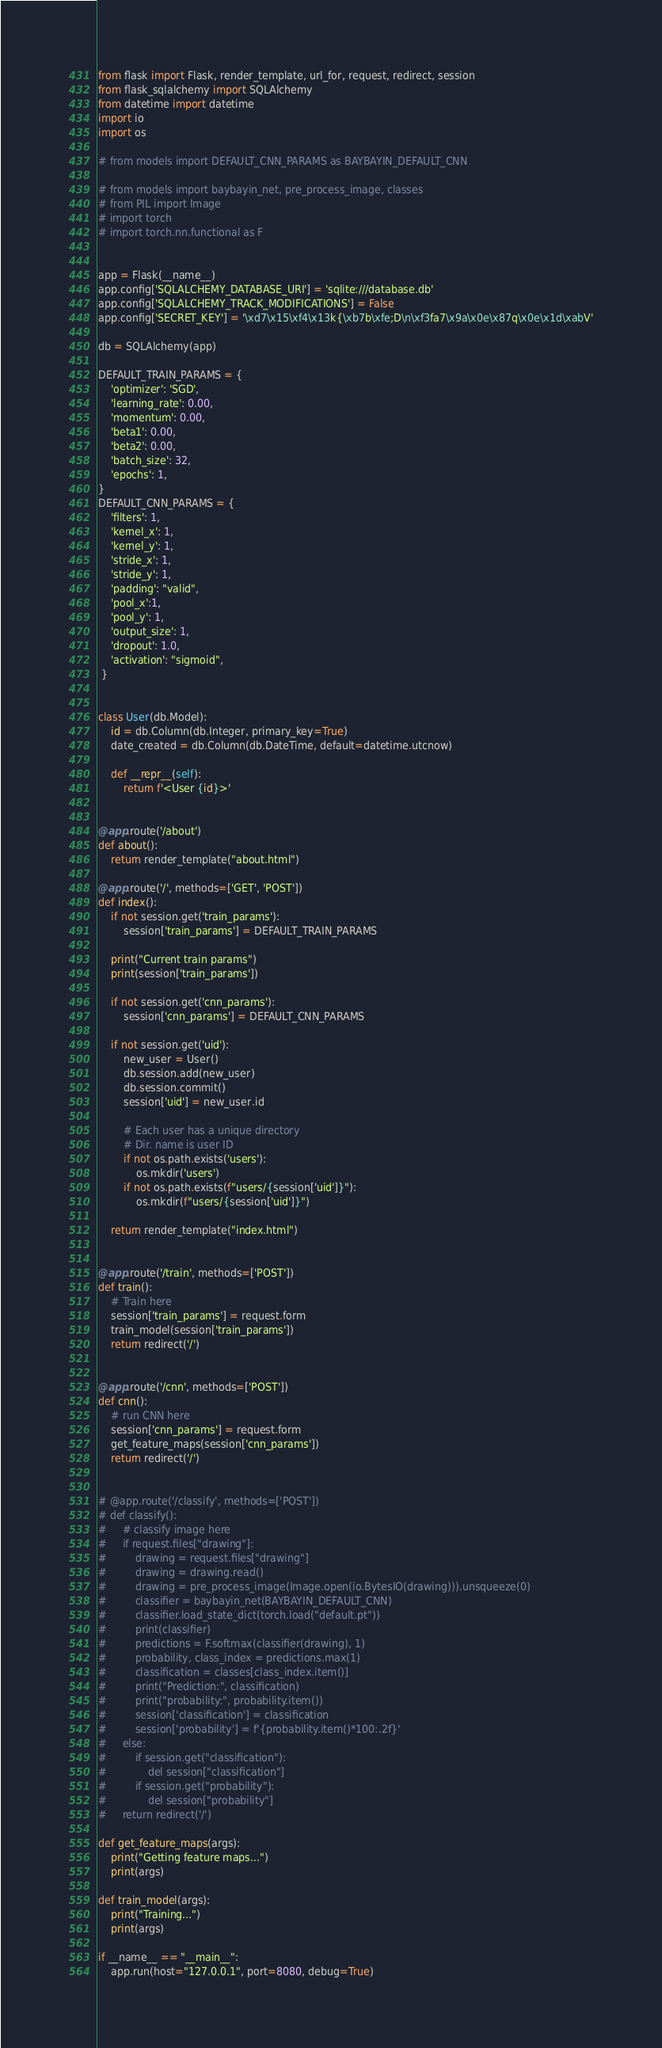Convert code to text. <code><loc_0><loc_0><loc_500><loc_500><_Python_>from flask import Flask, render_template, url_for, request, redirect, session
from flask_sqlalchemy import SQLAlchemy
from datetime import datetime
import io
import os

# from models import DEFAULT_CNN_PARAMS as BAYBAYIN_DEFAULT_CNN

# from models import baybayin_net, pre_process_image, classes
# from PIL import Image
# import torch
# import torch.nn.functional as F


app = Flask(__name__)
app.config['SQLALCHEMY_DATABASE_URI'] = 'sqlite:///database.db'
app.config['SQLALCHEMY_TRACK_MODIFICATIONS'] = False
app.config['SECRET_KEY'] = '\xd7\x15\xf4\x13k{\xb7b\xfe;D\n\xf3fa7\x9a\x0e\x87q\x0e\x1d\xabV'

db = SQLAlchemy(app)

DEFAULT_TRAIN_PARAMS = {
    'optimizer': 'SGD',
    'learning_rate': 0.00,
    'momentum': 0.00,
    'beta1': 0.00,
    'beta2': 0.00,
    'batch_size': 32,    
    'epochs': 1,
}
DEFAULT_CNN_PARAMS = {
    'filters': 1,
    'kernel_x': 1,
    'kernel_y': 1,
    'stride_x': 1,
    'stride_y': 1,
    'padding': "valid",
    'pool_x':1,
    'pool_y': 1,
    'output_size': 1,
    'dropout': 1.0,
    'activation': "sigmoid",
 }


class User(db.Model):
    id = db.Column(db.Integer, primary_key=True)
    date_created = db.Column(db.DateTime, default=datetime.utcnow)

    def __repr__(self):
        return f'<User {id}>'


@app.route('/about')
def about():
    return render_template("about.html")

@app.route('/', methods=['GET', 'POST'])
def index():
    if not session.get('train_params'):
        session['train_params'] = DEFAULT_TRAIN_PARAMS
    
    print("Current train params")
    print(session['train_params'])

    if not session.get('cnn_params'):
        session['cnn_params'] = DEFAULT_CNN_PARAMS

    if not session.get('uid'):
        new_user = User()
        db.session.add(new_user)
        db.session.commit()
        session['uid'] = new_user.id

        # Each user has a unique directory
        # Dir. name is user ID
        if not os.path.exists('users'):
            os.mkdir('users')
        if not os.path.exists(f"users/{session['uid']}"):
            os.mkdir(f"users/{session['uid']}")

    return render_template("index.html")


@app.route('/train', methods=['POST'])
def train():
    # Train here
    session['train_params'] = request.form
    train_model(session['train_params'])
    return redirect('/')


@app.route('/cnn', methods=['POST'])
def cnn():
    # run CNN here
    session['cnn_params'] = request.form
    get_feature_maps(session['cnn_params'])
    return redirect('/')


# @app.route('/classify', methods=['POST'])
# def classify():
#     # classify image here
#     if request.files["drawing"]:
#         drawing = request.files["drawing"]
#         drawing = drawing.read()
#         drawing = pre_process_image(Image.open(io.BytesIO(drawing))).unsqueeze(0)
#         classifier = baybayin_net(BAYBAYIN_DEFAULT_CNN)
#         classifier.load_state_dict(torch.load("default.pt"))
#         print(classifier)
#         predictions = F.softmax(classifier(drawing), 1)
#         probability, class_index = predictions.max(1)
#         classification = classes[class_index.item()]
#         print("Prediction:", classification)
#         print("probability:", probability.item())
#         session['classification'] = classification
#         session['probability'] = f'{probability.item()*100:.2f}'
#     else:
#         if session.get("classification"):
#             del session["classification"]
#         if session.get("probability"):
#             del session["probability"]
#     return redirect('/')

def get_feature_maps(args):
    print("Getting feature maps...")
    print(args)

def train_model(args):
    print("Training...")
    print(args)

if __name__ == "__main__":
    app.run(host="127.0.0.1", port=8080, debug=True)
</code> 